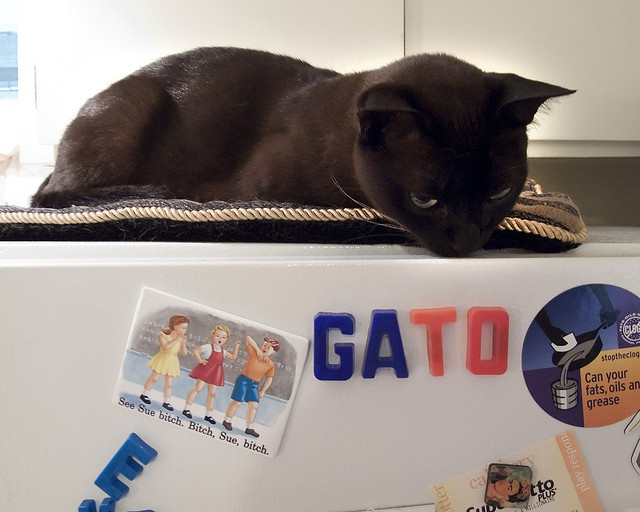Describe the objects in this image and their specific colors. I can see refrigerator in white, darkgray, and lightgray tones and cat in white, black, ivory, and gray tones in this image. 